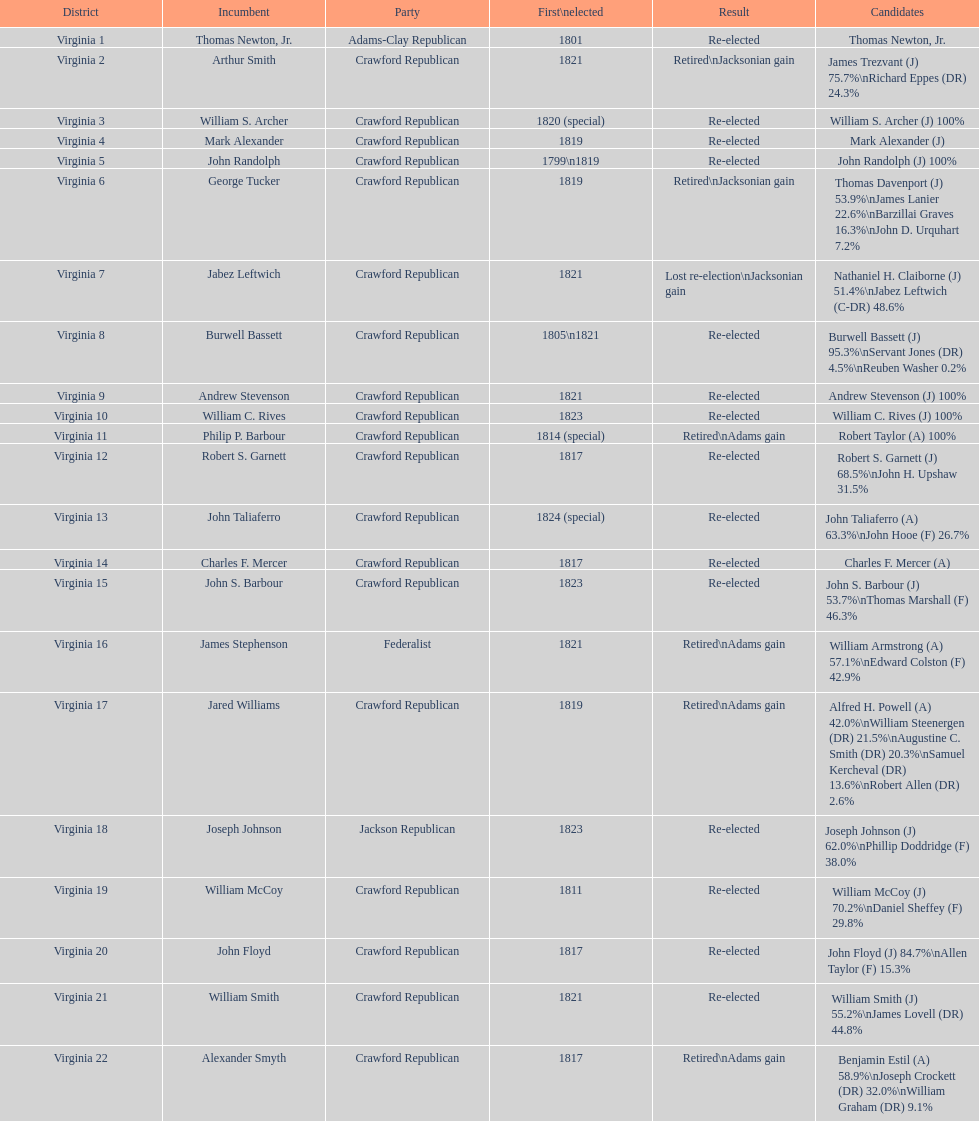What is the number of districts in virginia? 22. 